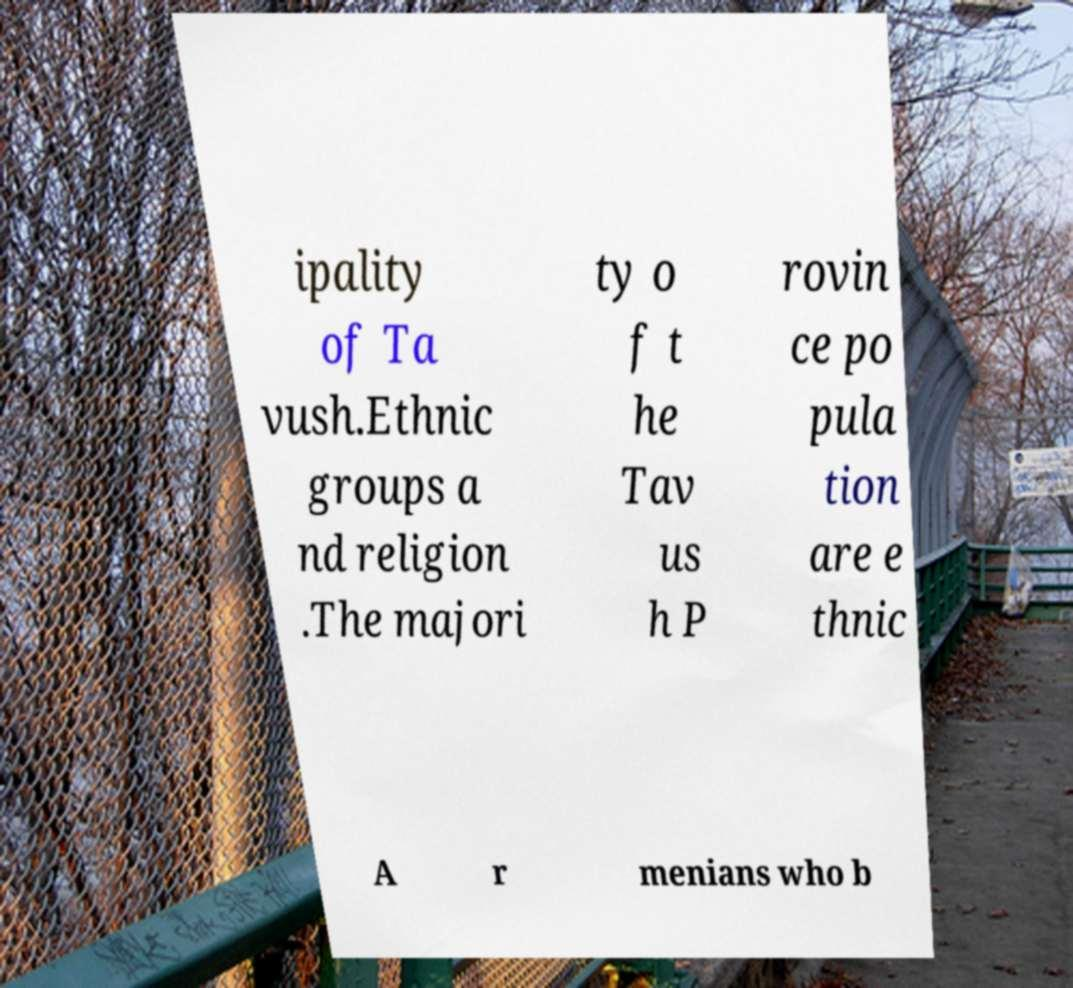What messages or text are displayed in this image? I need them in a readable, typed format. ipality of Ta vush.Ethnic groups a nd religion .The majori ty o f t he Tav us h P rovin ce po pula tion are e thnic A r menians who b 